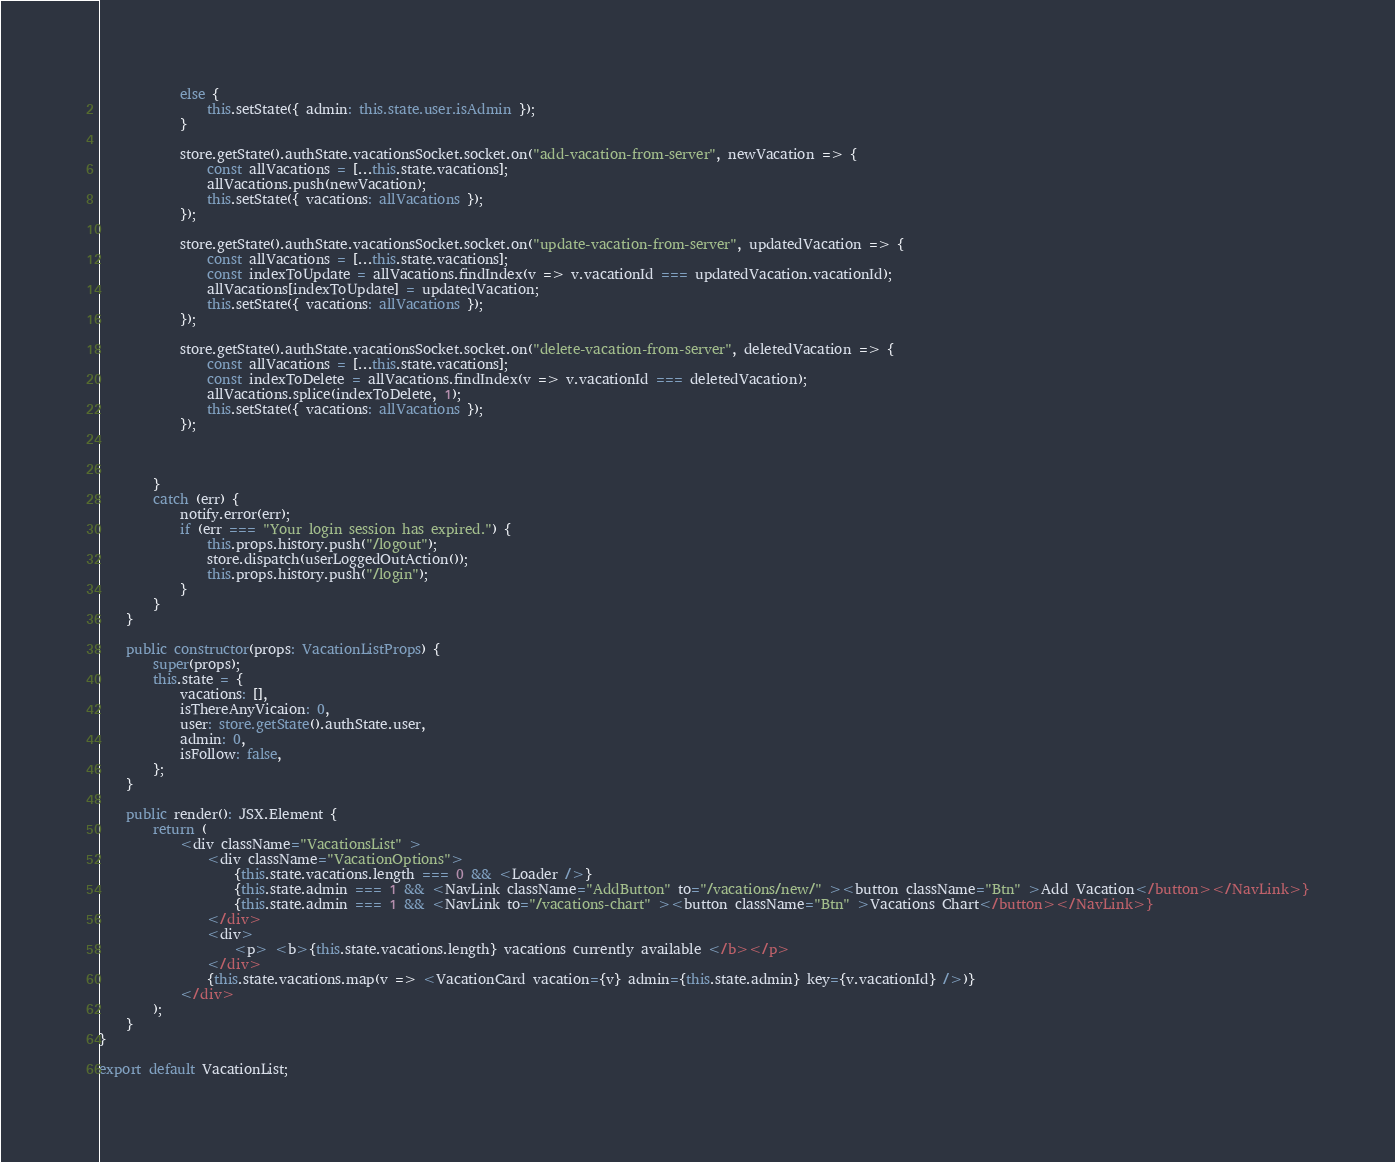<code> <loc_0><loc_0><loc_500><loc_500><_TypeScript_>            else {
                this.setState({ admin: this.state.user.isAdmin });
            }

            store.getState().authState.vacationsSocket.socket.on("add-vacation-from-server", newVacation => {
                const allVacations = [...this.state.vacations];
                allVacations.push(newVacation);
                this.setState({ vacations: allVacations });
            });

            store.getState().authState.vacationsSocket.socket.on("update-vacation-from-server", updatedVacation => {
                const allVacations = [...this.state.vacations];
                const indexToUpdate = allVacations.findIndex(v => v.vacationId === updatedVacation.vacationId);
                allVacations[indexToUpdate] = updatedVacation;
                this.setState({ vacations: allVacations });
            });

            store.getState().authState.vacationsSocket.socket.on("delete-vacation-from-server", deletedVacation => {
                const allVacations = [...this.state.vacations];
                const indexToDelete = allVacations.findIndex(v => v.vacationId === deletedVacation);
                allVacations.splice(indexToDelete, 1);
                this.setState({ vacations: allVacations });
            });



        }
        catch (err) {
            notify.error(err);
            if (err === "Your login session has expired.") {
                this.props.history.push("/logout");
                store.dispatch(userLoggedOutAction());
                this.props.history.push("/login");
            }
        }
    }

    public constructor(props: VacationListProps) {
        super(props);
        this.state = {
            vacations: [],
            isThereAnyVicaion: 0,
            user: store.getState().authState.user,
            admin: 0,
            isFollow: false,
        };
    }

    public render(): JSX.Element {
        return (
            <div className="VacationsList" >
                <div className="VacationOptions">
                    {this.state.vacations.length === 0 && <Loader />}
                    {this.state.admin === 1 && <NavLink className="AddButton" to="/vacations/new/" ><button className="Btn" >Add Vacation</button></NavLink>}
                    {this.state.admin === 1 && <NavLink to="/vacations-chart" ><button className="Btn" >Vacations Chart</button></NavLink>}
                </div>
                <div>
                    <p> <b>{this.state.vacations.length} vacations currently available </b></p>
                </div>
                {this.state.vacations.map(v => <VacationCard vacation={v} admin={this.state.admin} key={v.vacationId} />)}
            </div>
        );
    }
}

export default VacationList;
</code> 